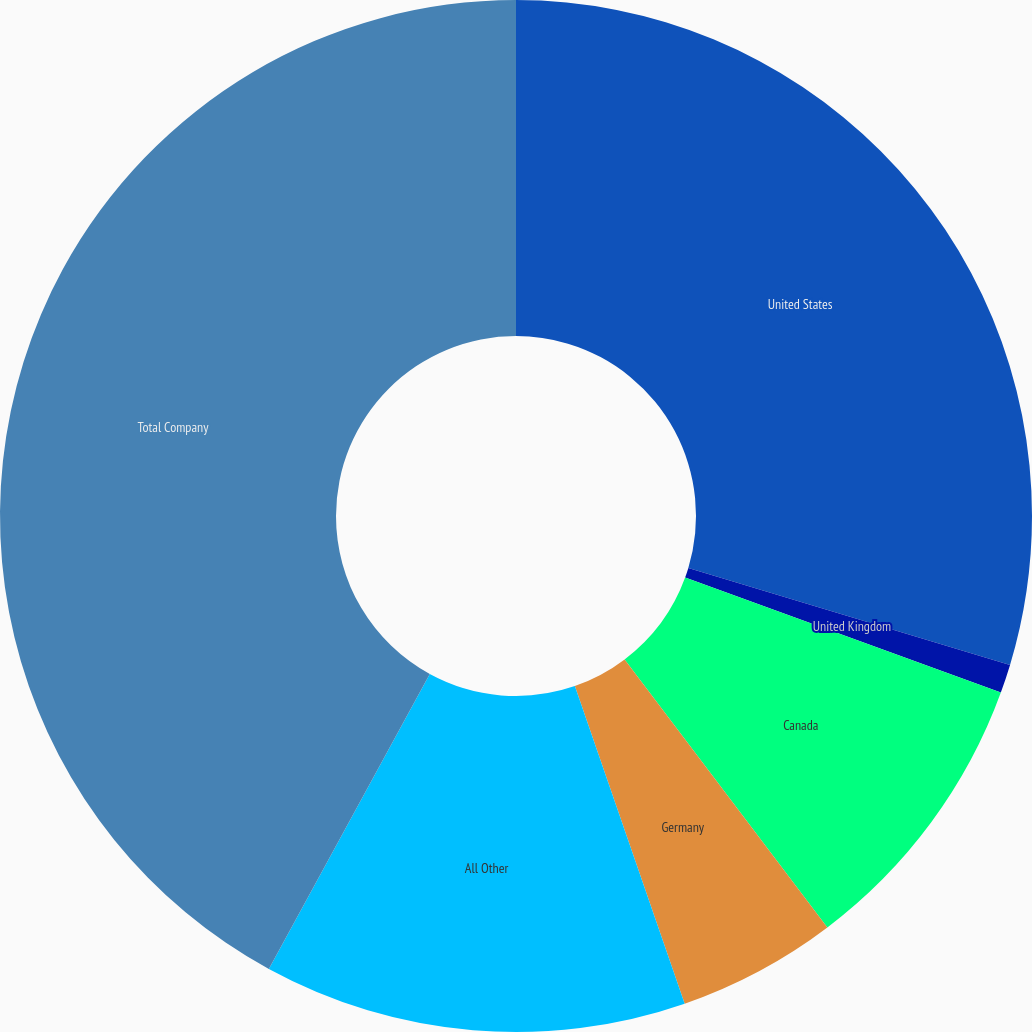Convert chart. <chart><loc_0><loc_0><loc_500><loc_500><pie_chart><fcel>United States<fcel>United Kingdom<fcel>Canada<fcel>Germany<fcel>All Other<fcel>Total Company<nl><fcel>29.66%<fcel>0.9%<fcel>9.13%<fcel>5.01%<fcel>13.25%<fcel>42.05%<nl></chart> 